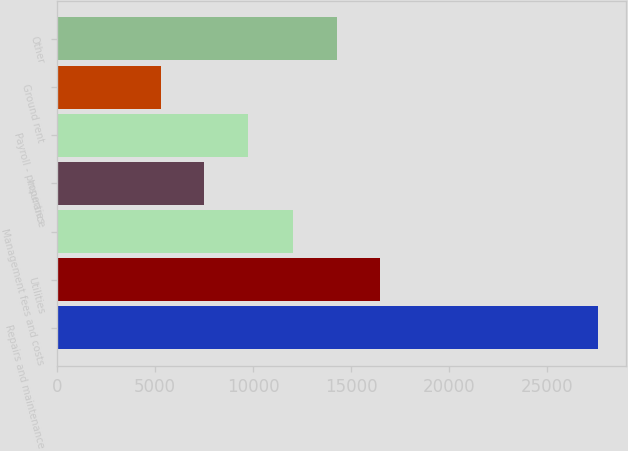Convert chart. <chart><loc_0><loc_0><loc_500><loc_500><bar_chart><fcel>Repairs and maintenance<fcel>Utilities<fcel>Management fees and costs<fcel>Insurance<fcel>Payroll - properties<fcel>Ground rent<fcel>Other<nl><fcel>27617<fcel>16491.2<fcel>12024<fcel>7514.6<fcel>9748.2<fcel>5281<fcel>14257.6<nl></chart> 